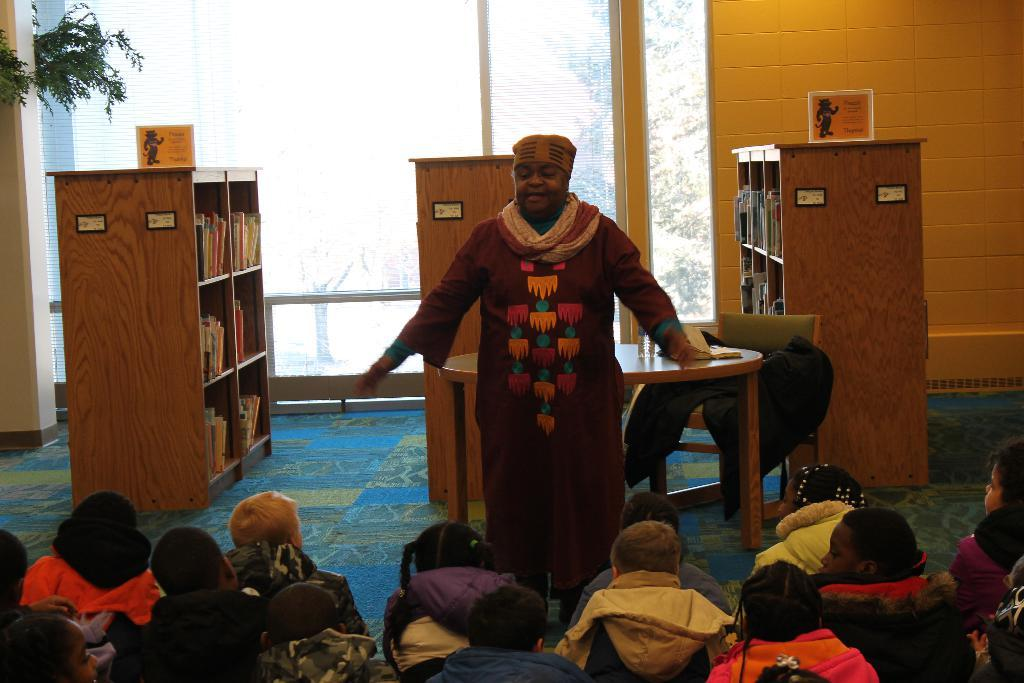What can be seen in the image that provides a view of the outside? There is a window in the image that provides a view of the outside. Who is present in the image? There is a man standing in the image, and there are people sitting on the floor. What furniture is visible in the image? There is a table in the image. How many racks are present in the image? There are three racks in the image. What type of war is being depicted in the image? There is no depiction of war in the image; it features a window, a man, a table, three racks, and people sitting on the floor. What kind of fowl can be seen in the image? There are no fowl present in the image. 